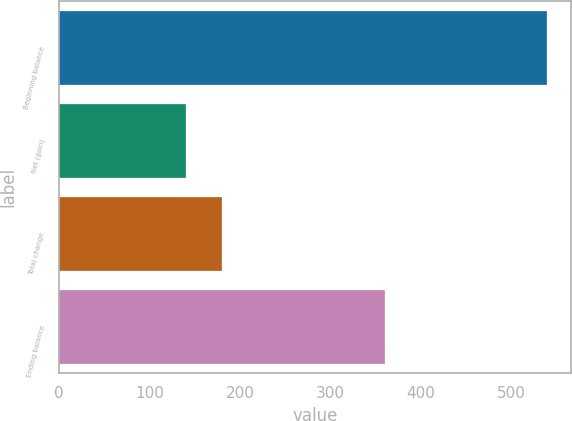Convert chart. <chart><loc_0><loc_0><loc_500><loc_500><bar_chart><fcel>Beginning balance<fcel>Net (gain)<fcel>Total change<fcel>Ending balance<nl><fcel>539<fcel>141<fcel>180.8<fcel>360<nl></chart> 